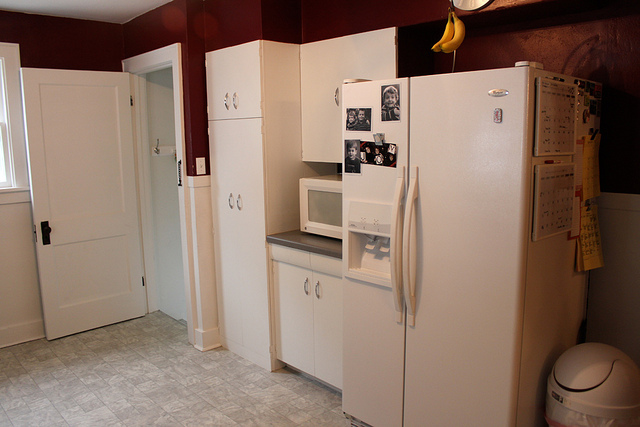How many bananas do they have? There is one bunch of bananas consisting of three individual bananas hanging from a banana holder on top of the fridge. 